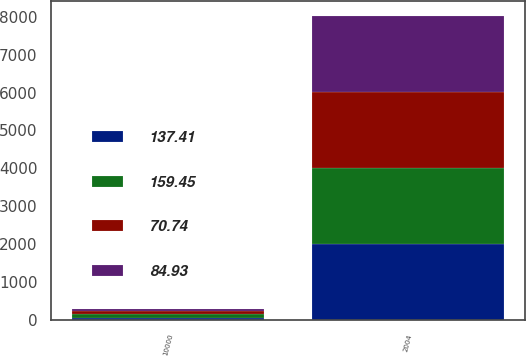Convert chart. <chart><loc_0><loc_0><loc_500><loc_500><stacked_bar_chart><ecel><fcel>2004<fcel>10000<nl><fcel>159.45<fcel>2005<fcel>93.99<nl><fcel>84.93<fcel>2006<fcel>63.69<nl><fcel>70.74<fcel>2007<fcel>85.49<nl><fcel>137.41<fcel>2008<fcel>54<nl></chart> 